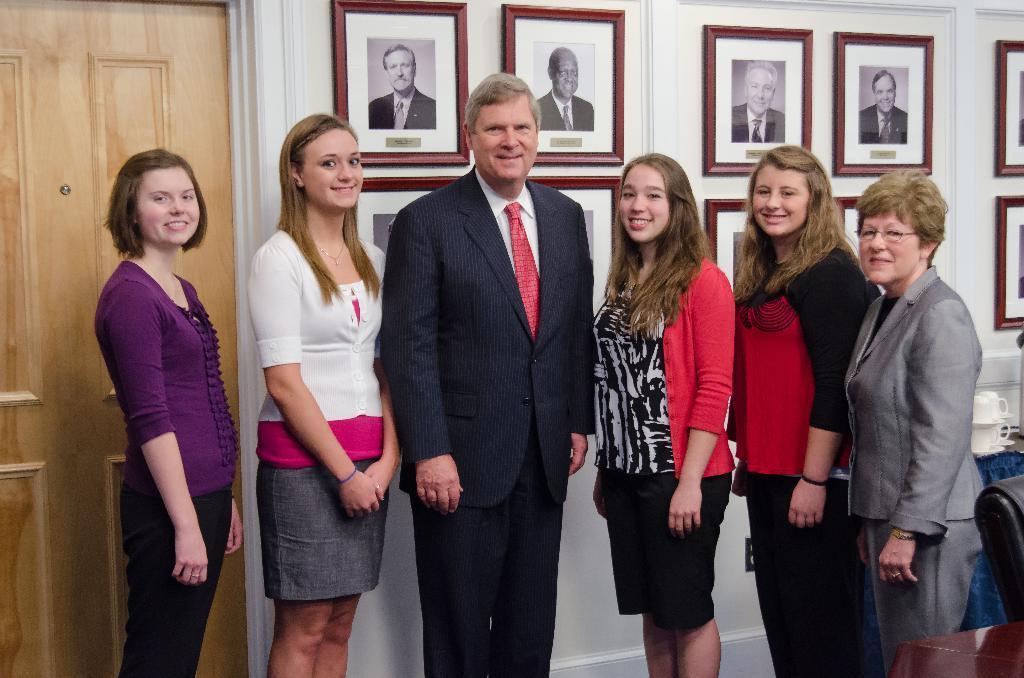In one or two sentences, can you explain what this image depicts? In this image I can see a group of people standing. On the left side I can see a door. In the background, I can see the photo frames on the wall. 